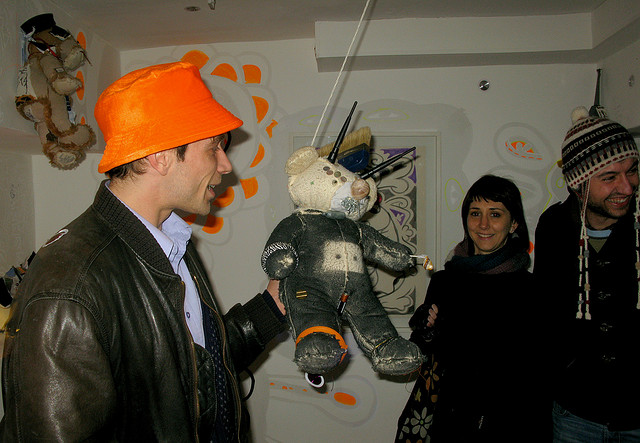<image>What is on the floor in the back? I don't know what's on the floor in the back. It can be an animal, a rug, or a bear. What is on the floor in the back? I am not sure what is on the floor in the back. It can be seen 'animal', 'tile', 'rug', 'bear', 'washing machine', or 'orange paint'. 